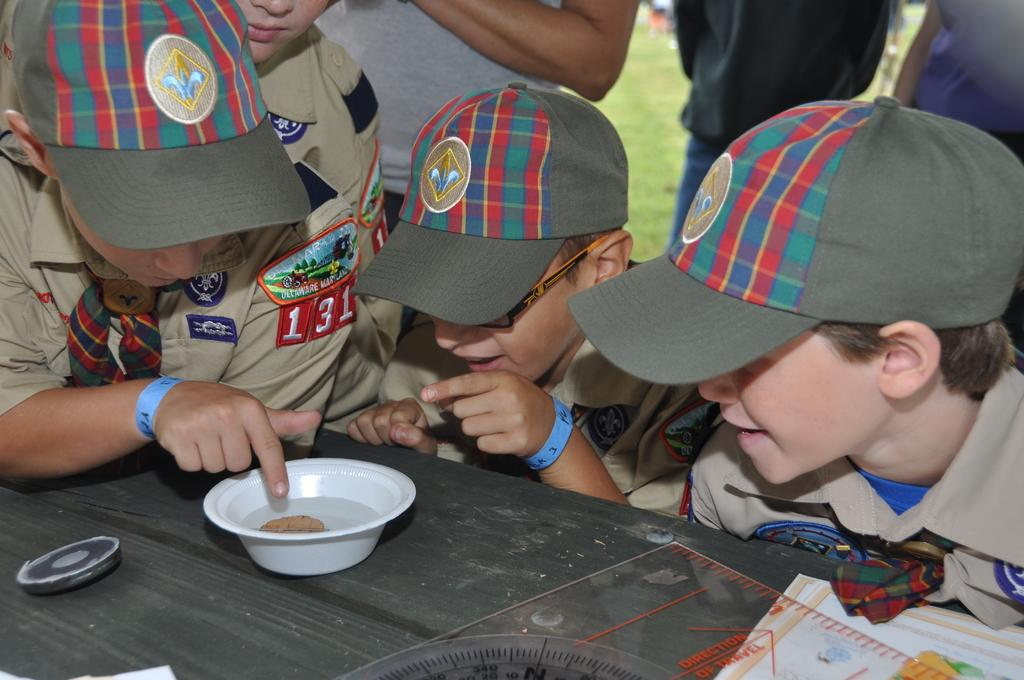What can be seen in the image? There are kids in the image. What are the kids wearing? The kids are wearing hats. What is in front of the kids? There is a table in front of the kids. What is on the table? There is a paper cup on the table, along with other objects. What is the name of the snake that is crawling on the table in the image? There is no snake present in the image; it only features kids wearing hats and a table with a paper cup and other objects. 